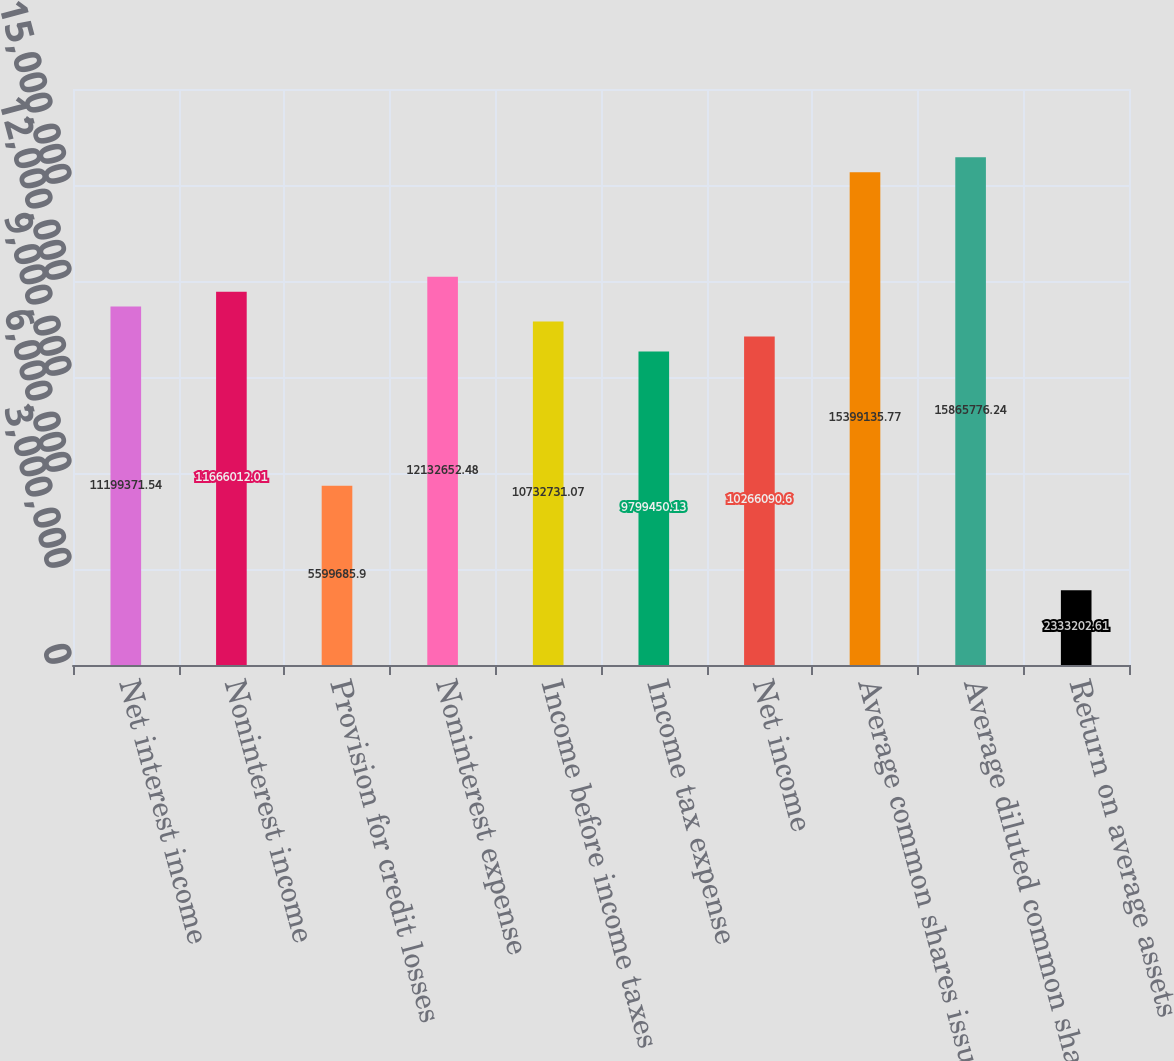Convert chart to OTSL. <chart><loc_0><loc_0><loc_500><loc_500><bar_chart><fcel>Net interest income<fcel>Noninterest income<fcel>Provision for credit losses<fcel>Noninterest expense<fcel>Income before income taxes<fcel>Income tax expense<fcel>Net income<fcel>Average common shares issued<fcel>Average diluted common shares<fcel>Return on average assets<nl><fcel>1.11994e+07<fcel>1.1666e+07<fcel>5.59969e+06<fcel>1.21327e+07<fcel>1.07327e+07<fcel>9.79945e+06<fcel>1.02661e+07<fcel>1.53991e+07<fcel>1.58658e+07<fcel>2.3332e+06<nl></chart> 